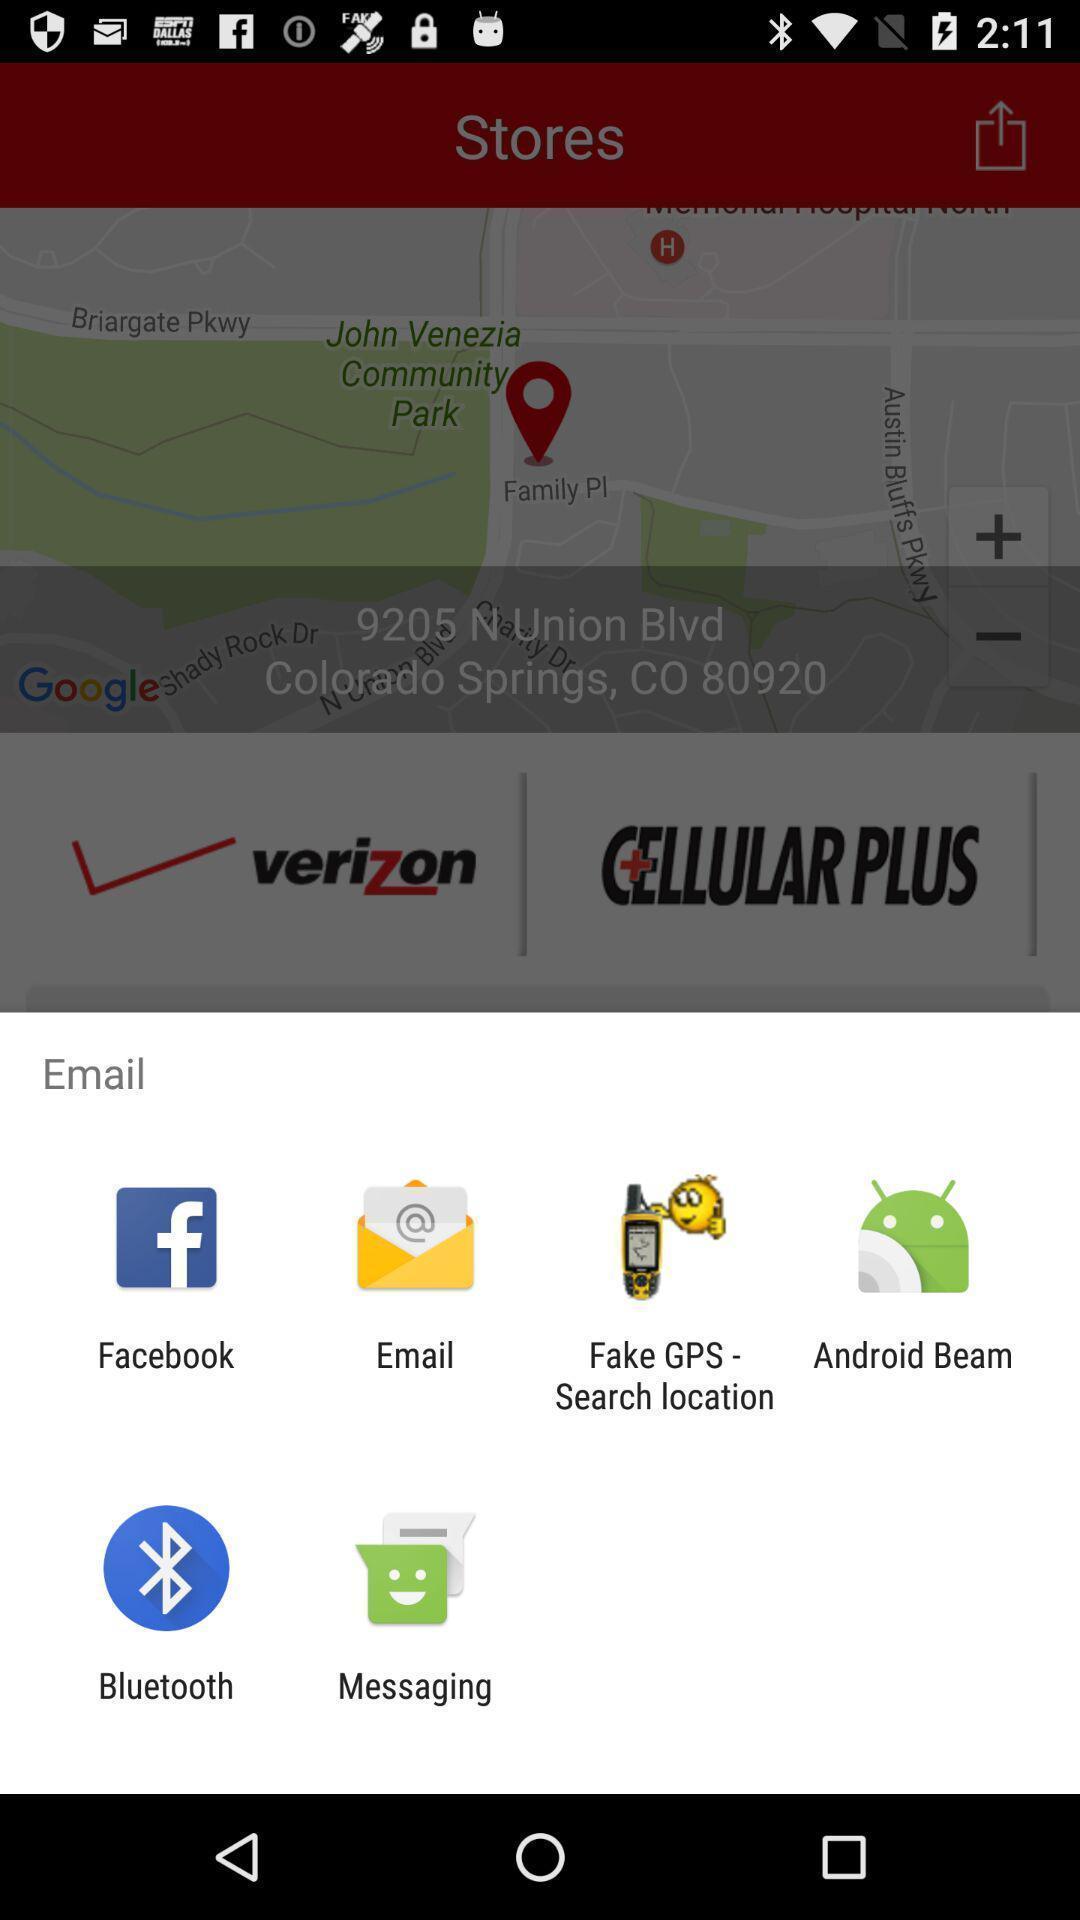Describe this image in words. Popup displaying multiple options to select. 